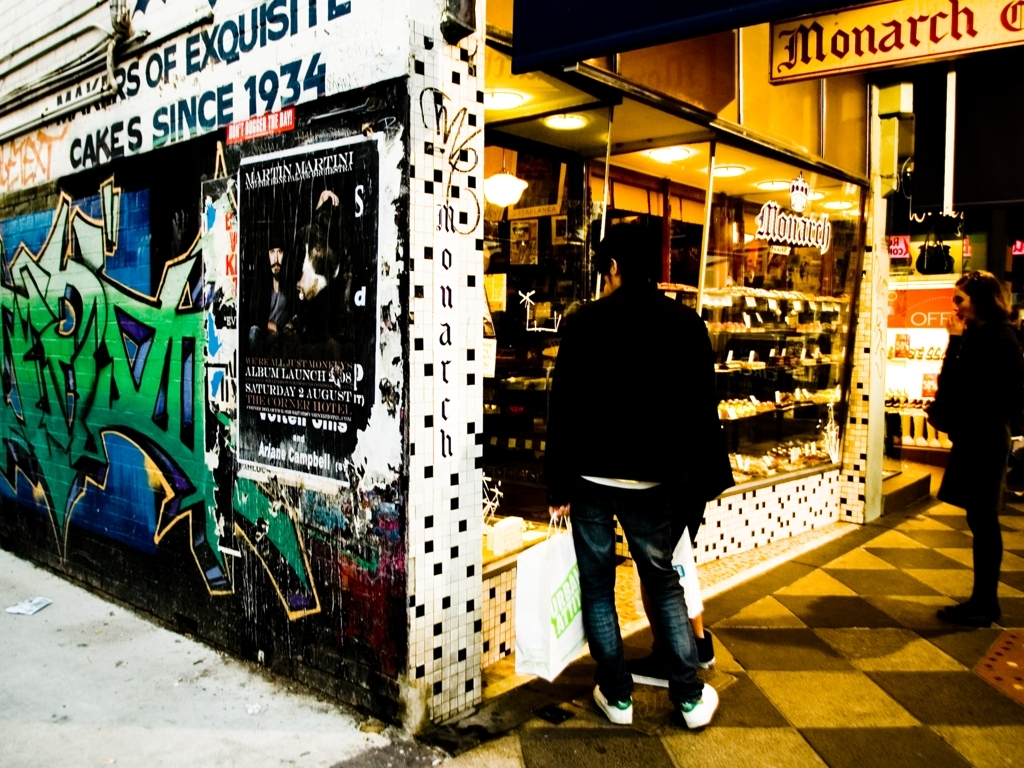Has the background lost a significant amount of texture detail?
A. Yes
B. No
Answer with the option's letter from the given choices directly.
 A. 